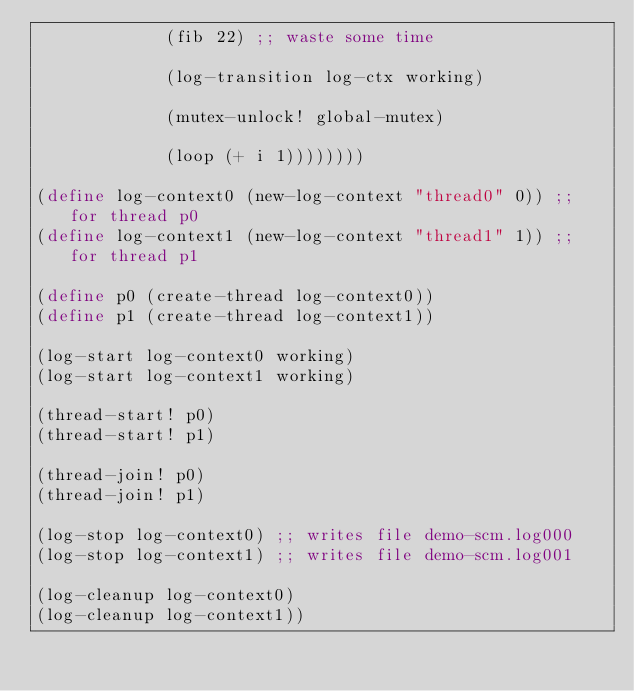<code> <loc_0><loc_0><loc_500><loc_500><_Scheme_>             (fib 22) ;; waste some time

             (log-transition log-ctx working)

             (mutex-unlock! global-mutex)

             (loop (+ i 1))))))))

(define log-context0 (new-log-context "thread0" 0)) ;; for thread p0
(define log-context1 (new-log-context "thread1" 1)) ;; for thread p1

(define p0 (create-thread log-context0))
(define p1 (create-thread log-context1))

(log-start log-context0 working)
(log-start log-context1 working)

(thread-start! p0)
(thread-start! p1)

(thread-join! p0)
(thread-join! p1)

(log-stop log-context0) ;; writes file demo-scm.log000
(log-stop log-context1) ;; writes file demo-scm.log001

(log-cleanup log-context0)
(log-cleanup log-context1))
</code> 